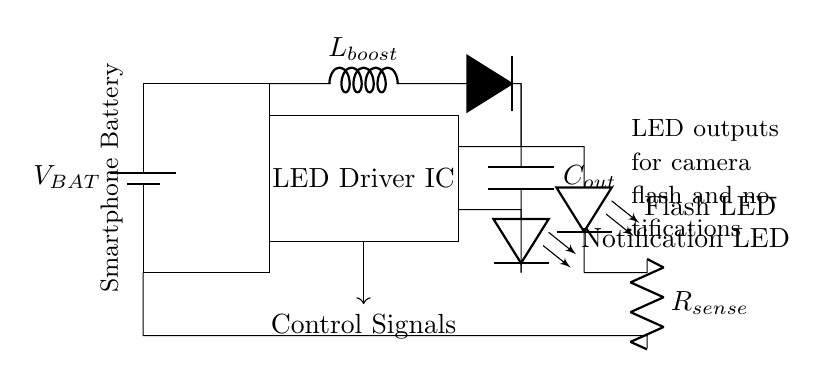What is the power source for this circuit? The power source for this circuit is labeled as V_BAT, which signifies the battery of the smartphone providing the necessary voltage.
Answer: V_BAT What components are used for LED illumination? The circuit contains two LEDs, one labeled as Flash LED and the other as Notification LED. These components are responsible for providing light notifications to the smartphone user.
Answer: Flash LED, Notification LED What is the function of R_sense in this circuit? R_sense is a current-sensing resistor that is used to measure the current flowing through the LEDs. This allows for monitoring and adjusting the current to ensure the LEDs operate correctly without damaging them.
Answer: Current sensing How do control signals affect the LED driver? The control signals, shown as an arrow leading from the LED Driver IC, govern the operation of the driver, determining when and at what intensity the LEDs are activated based on user settings or system events.
Answer: Regulate LED activity What does L_boost represent in the circuit? L_boost is an inductor used in the circuit's boost converter section, which steps up the voltage to a level suitable for powering the LEDs, ensuring they receive adequate power for optimal brightness.
Answer: Inductor Which component smooths out the output voltage from the boost converter? The component labeled C_out is a capacitor that smooths the output voltage, filtering out any fluctuations and providing a stable DC voltage supply to the LEDs.
Answer: Capacitor What would happen if the LED Driver IC fails? If the LED Driver IC fails, both the Flash LED and Notification LED would stop functioning, leading to no visual notifications or flash capability for the device, severely impacting the user experience.
Answer: Inoperative LEDs 